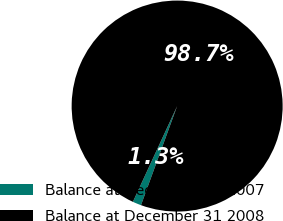<chart> <loc_0><loc_0><loc_500><loc_500><pie_chart><fcel>Balance at December 31 2007<fcel>Balance at December 31 2008<nl><fcel>1.32%<fcel>98.68%<nl></chart> 